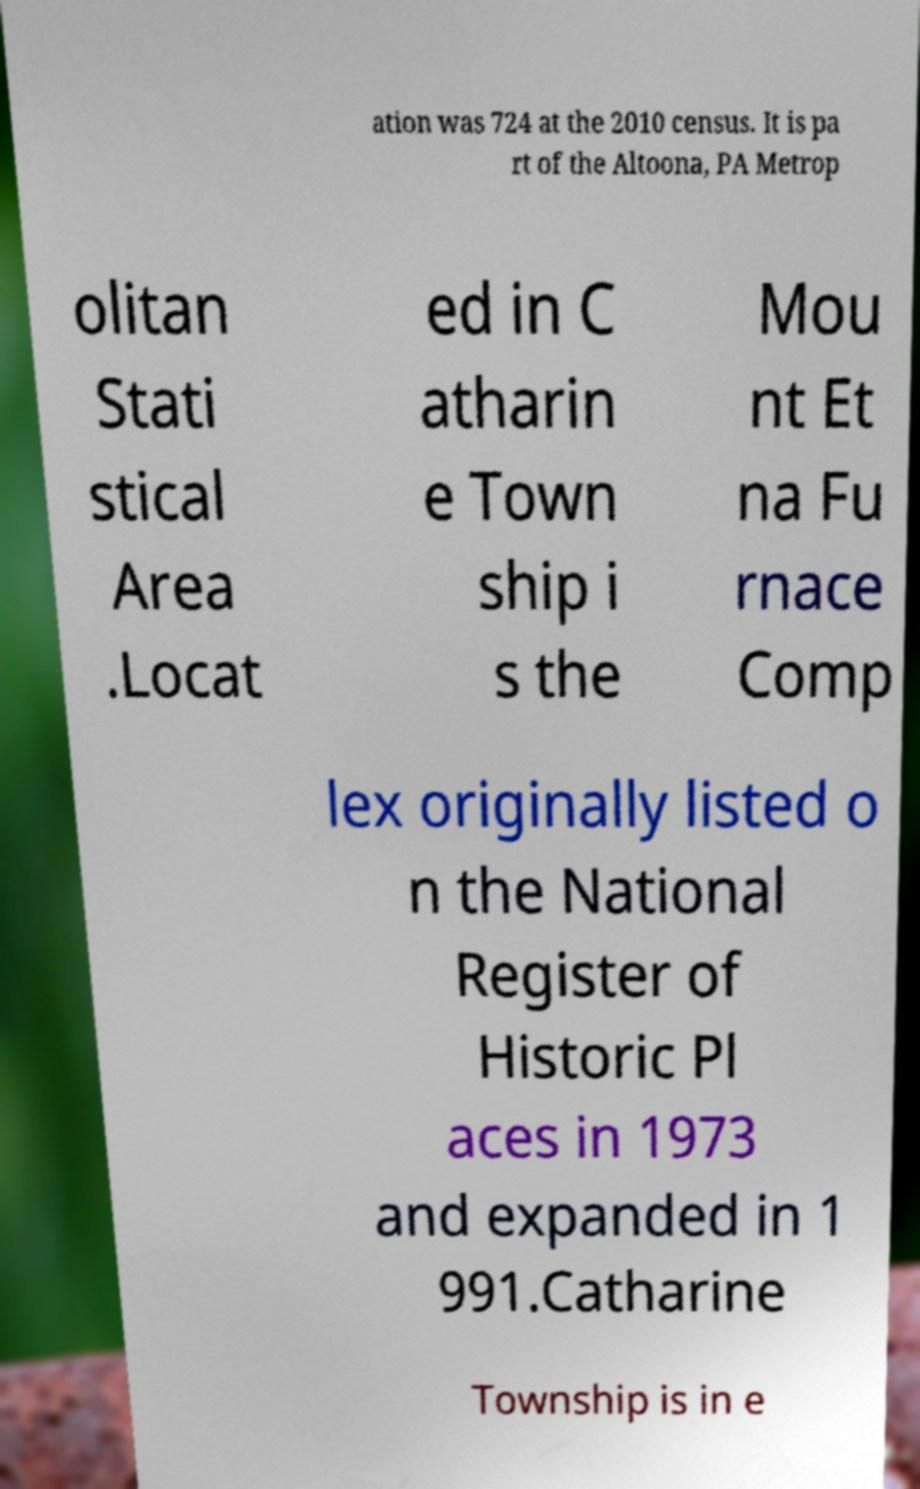Could you assist in decoding the text presented in this image and type it out clearly? ation was 724 at the 2010 census. It is pa rt of the Altoona, PA Metrop olitan Stati stical Area .Locat ed in C atharin e Town ship i s the Mou nt Et na Fu rnace Comp lex originally listed o n the National Register of Historic Pl aces in 1973 and expanded in 1 991.Catharine Township is in e 